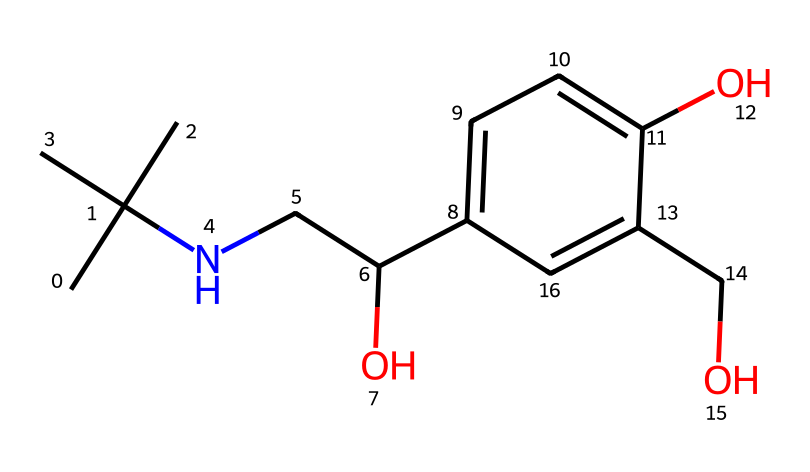what is the name of this chemical? The SMILES representation corresponds to albuterol, a bronchodilator used in the treatment of respiratory conditions.
Answer: albuterol how many carbon atoms are present in this structure? By analyzing the SMILES, we count the "C" characters: there are a total of nine carbon atoms in the structure.
Answer: nine what type of bonding primarily occurs between the carbon atoms in this chemical? The structure primarily consists of single bonds (sigma bonds) between the carbon atoms, except for the presence of aromatic rings which contain conjugated pi bonds.
Answer: single bonds how many hydroxyl (OH) groups are present in the chemical? In the given structure, we can identify two "O" characters attached to "H," which indicates the presence of two hydroxyl groups.
Answer: two which part of this chemical contributes to its lipophilicity? The multiple carbon chains and alkyl groups provide substantial lipophilicity, enhancing the compound's ability to penetrate cell membranes.
Answer: carbon chains what effect does the presence of the amine group have on the chemical's properties? The amine group (NH) enhances solubility in water and contributes to its activity as a bronchodilator by interacting with receptors in the lungs.
Answer: increases solubility how does the aromatic ring system affect the chemical's activity as a medication? The aromatic ring system stabilizes the molecular structure and allows for effective interaction with beta-adrenergic receptors, making it an efficient medication for respiratory treatments.
Answer: enhances interaction 